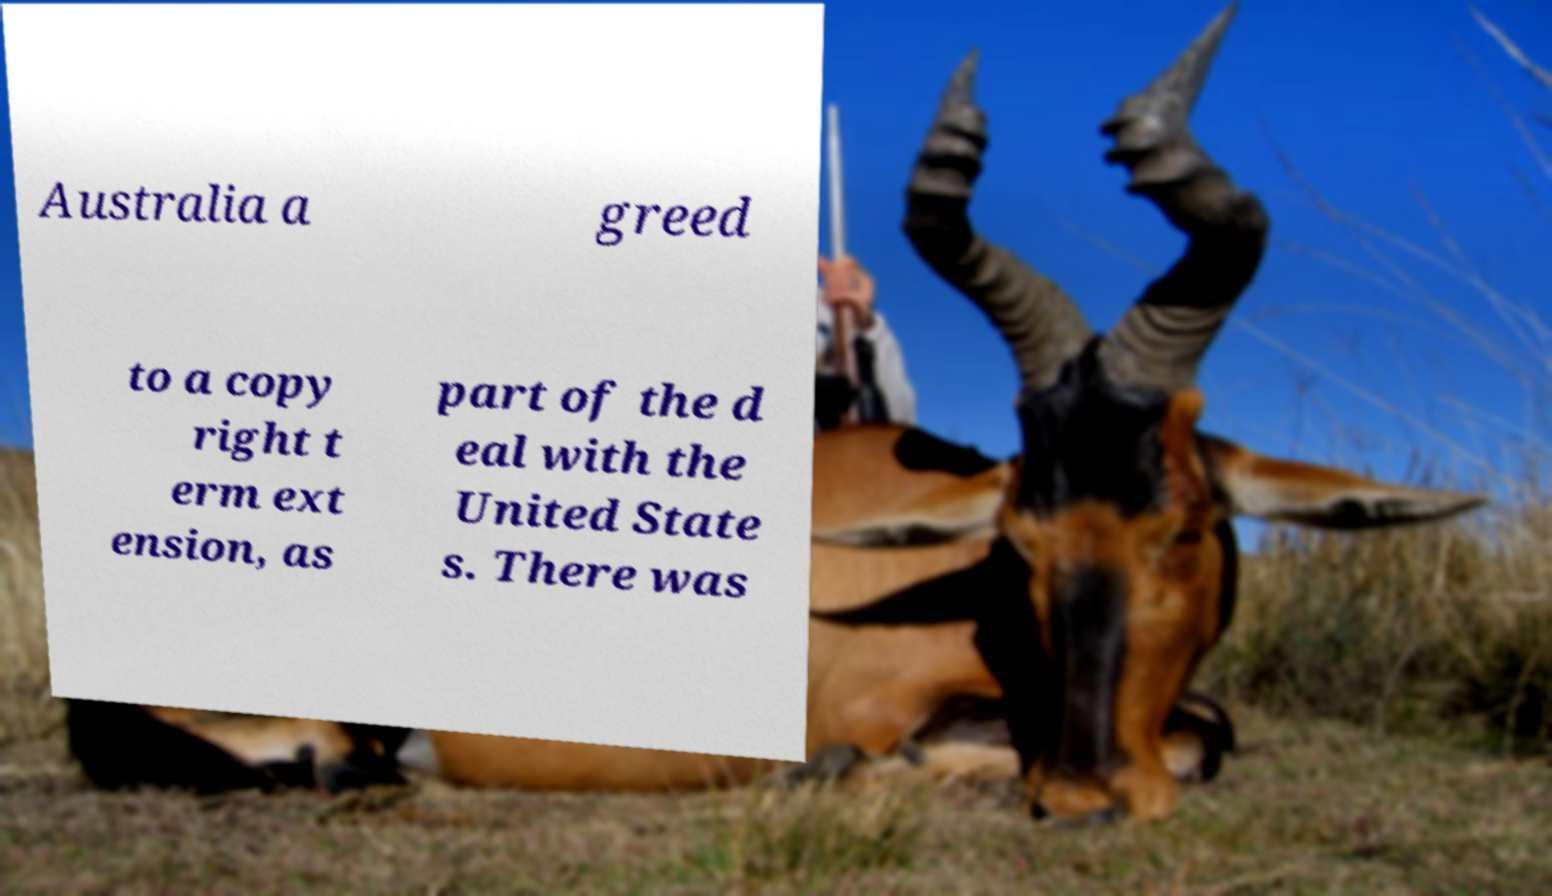Could you extract and type out the text from this image? Australia a greed to a copy right t erm ext ension, as part of the d eal with the United State s. There was 